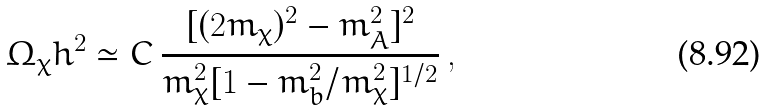Convert formula to latex. <formula><loc_0><loc_0><loc_500><loc_500>\Omega _ { \chi } h ^ { 2 } \simeq C \, \frac { [ ( 2 m _ { \chi } ) ^ { 2 } - m _ { A } ^ { 2 } ] ^ { 2 } } { m _ { \chi } ^ { 2 } [ 1 - m _ { b } ^ { 2 } / m _ { \chi } ^ { 2 } ] ^ { 1 / 2 } } \, ,</formula> 